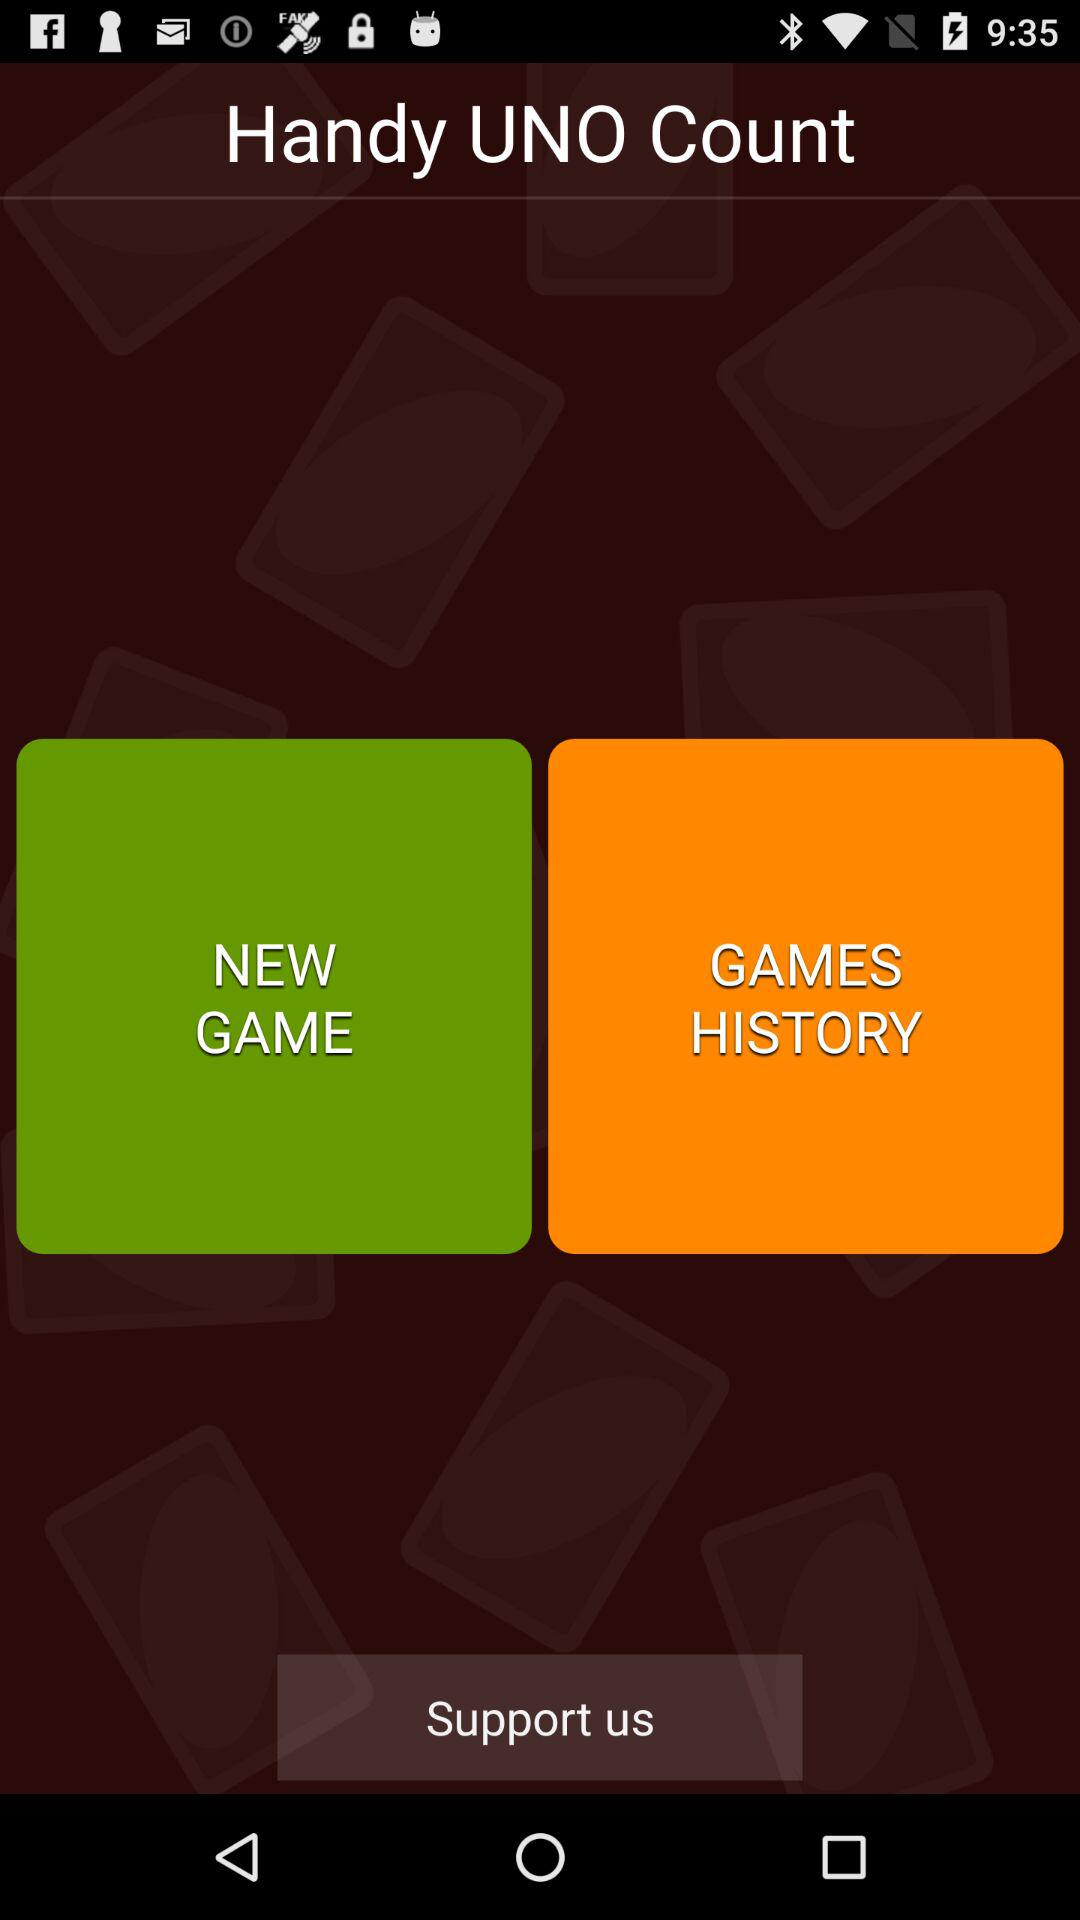What is the name of the application? The name of the application is "Handy UNO Count". 